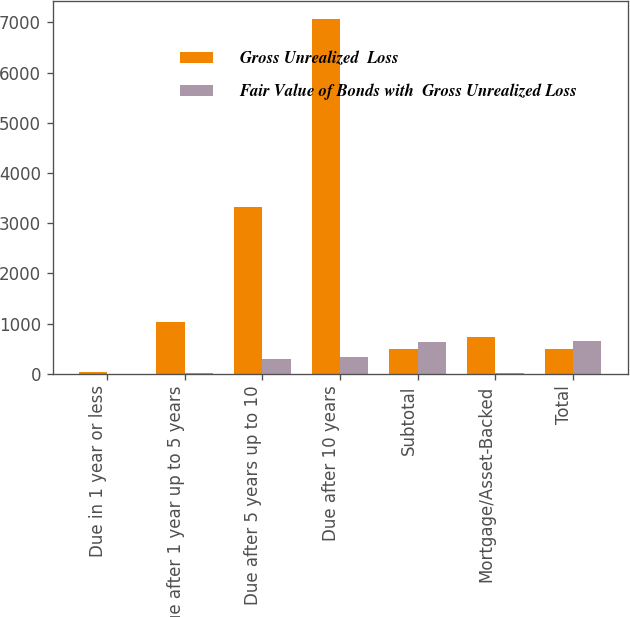Convert chart to OTSL. <chart><loc_0><loc_0><loc_500><loc_500><stacked_bar_chart><ecel><fcel>Due in 1 year or less<fcel>Due after 1 year up to 5 years<fcel>Due after 5 years up to 10<fcel>Due after 10 years<fcel>Subtotal<fcel>Mortgage/Asset-Backed<fcel>Total<nl><fcel>Gross Unrealized  Loss<fcel>33.6<fcel>1031<fcel>3326.5<fcel>7076.5<fcel>486.25<fcel>737<fcel>486.25<nl><fcel>Fair Value of Bonds with  Gross Unrealized Loss<fcel>0.1<fcel>11.5<fcel>289.9<fcel>335.5<fcel>637<fcel>13.8<fcel>650.8<nl></chart> 